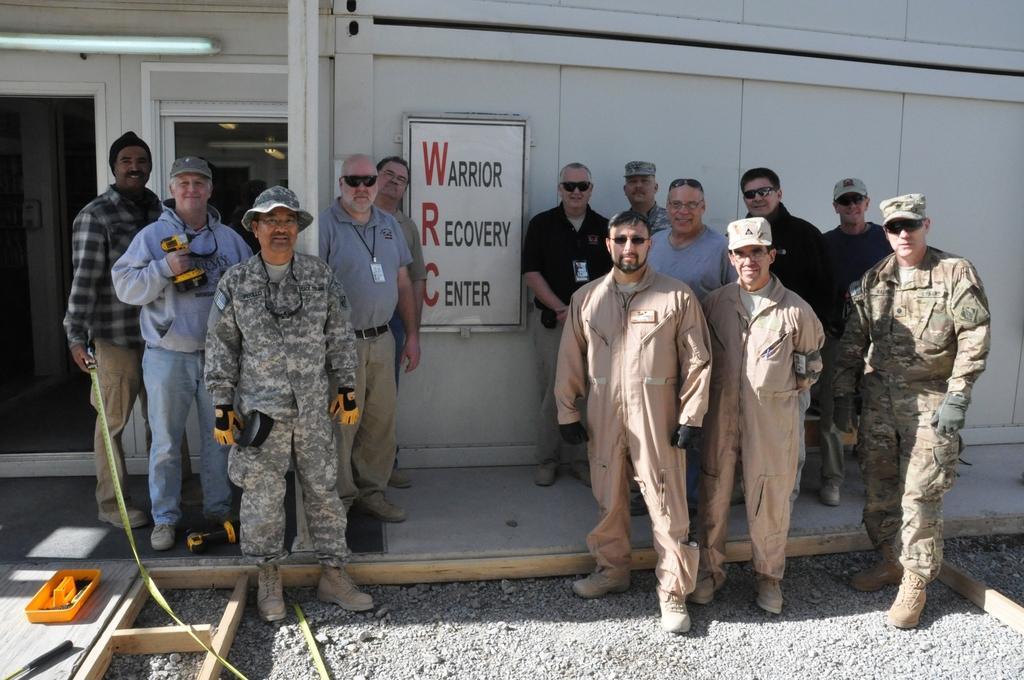How would you summarize this image in a sentence or two? In this image we can see a group of people standing on the surface. In that a man is holding a tape and the other is holding a hand drill. On the backside we can see a building with windows, a tube light and a board with some text on it. On the left side we can see a container and a tool on the surface. 